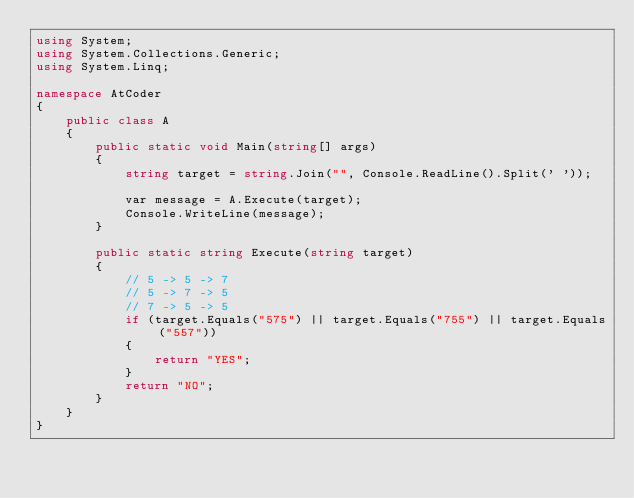Convert code to text. <code><loc_0><loc_0><loc_500><loc_500><_C#_>using System;
using System.Collections.Generic;
using System.Linq;

namespace AtCoder
{
    public class A
    {
        public static void Main(string[] args)
        {
            string target = string.Join("", Console.ReadLine().Split(' '));

            var message = A.Execute(target);
            Console.WriteLine(message);
        }

        public static string Execute(string target)
        {
            // 5 -> 5 -> 7
            // 5 -> 7 -> 5
            // 7 -> 5 -> 5
            if (target.Equals("575") || target.Equals("755") || target.Equals("557"))
            {
                return "YES";
            }
            return "NO";
        }
    }
}</code> 